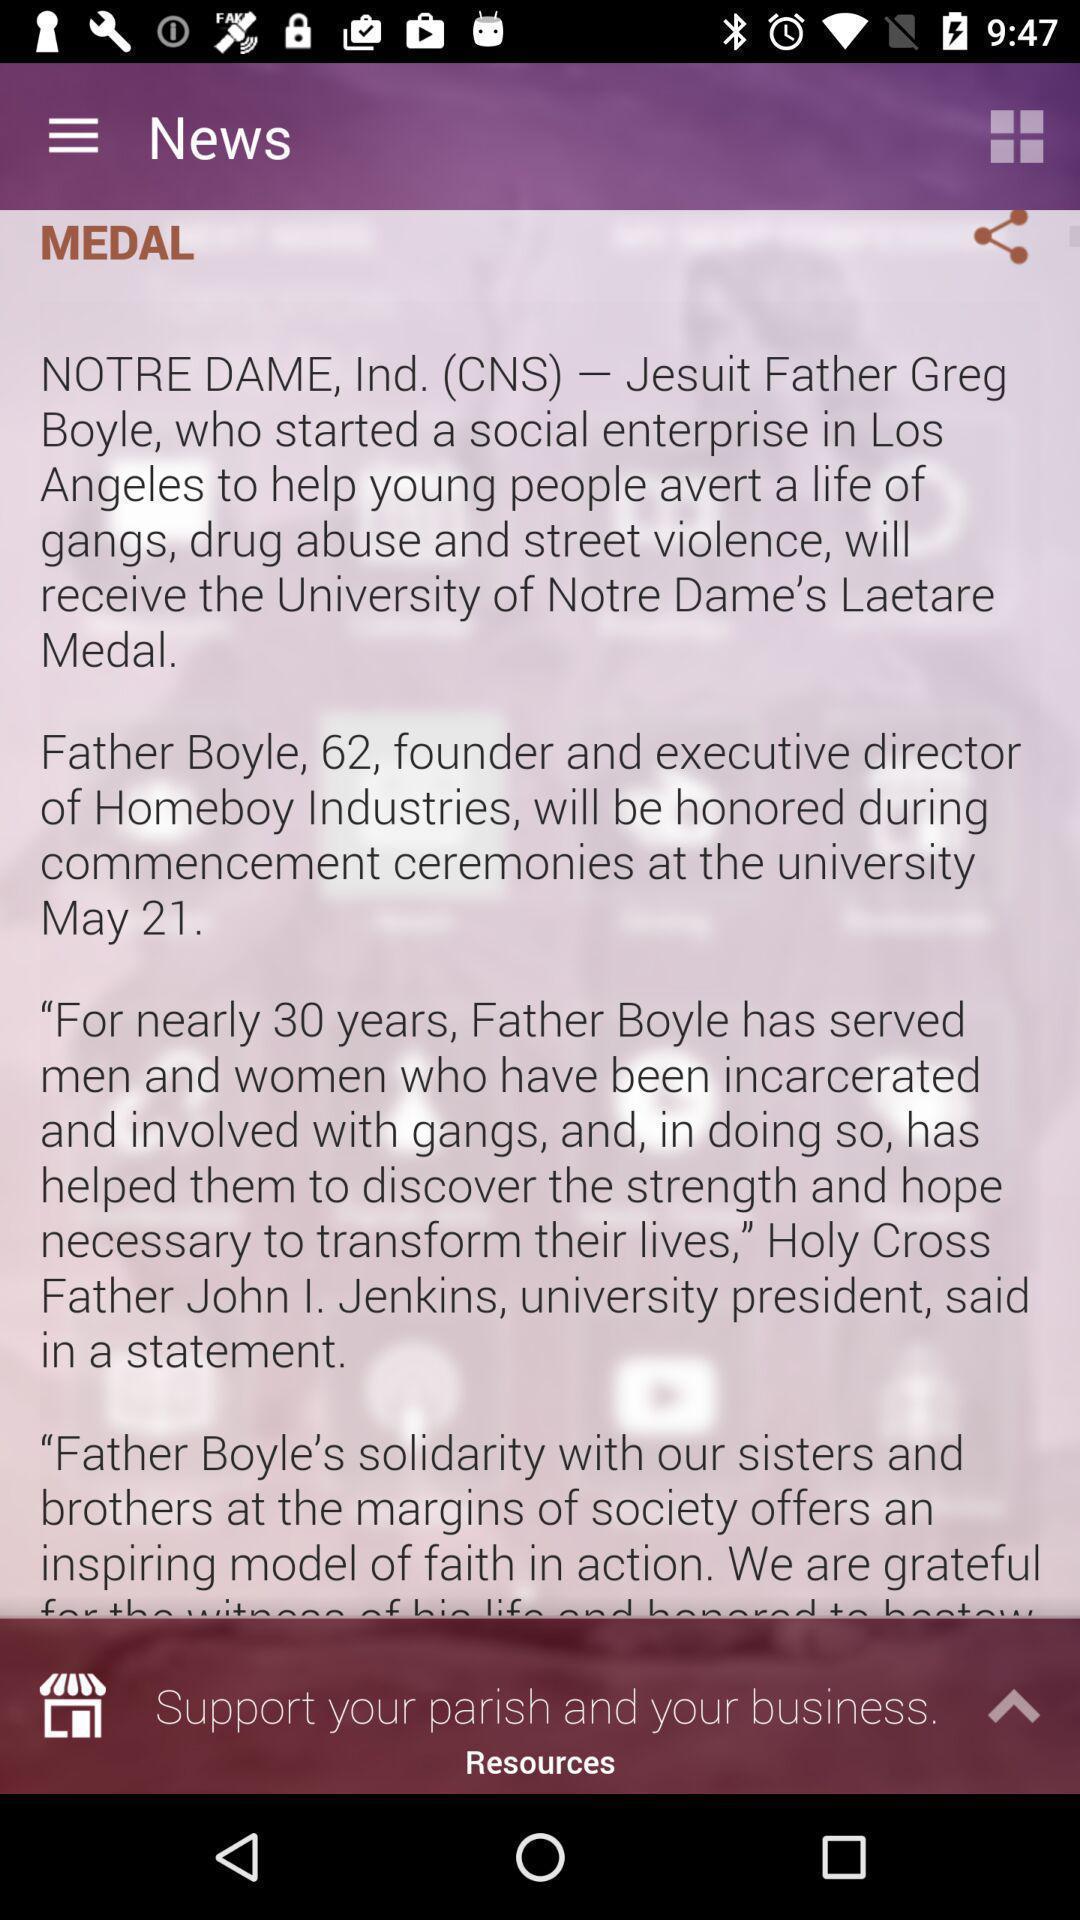Tell me about the visual elements in this screen capture. Screen shows about medal news. 